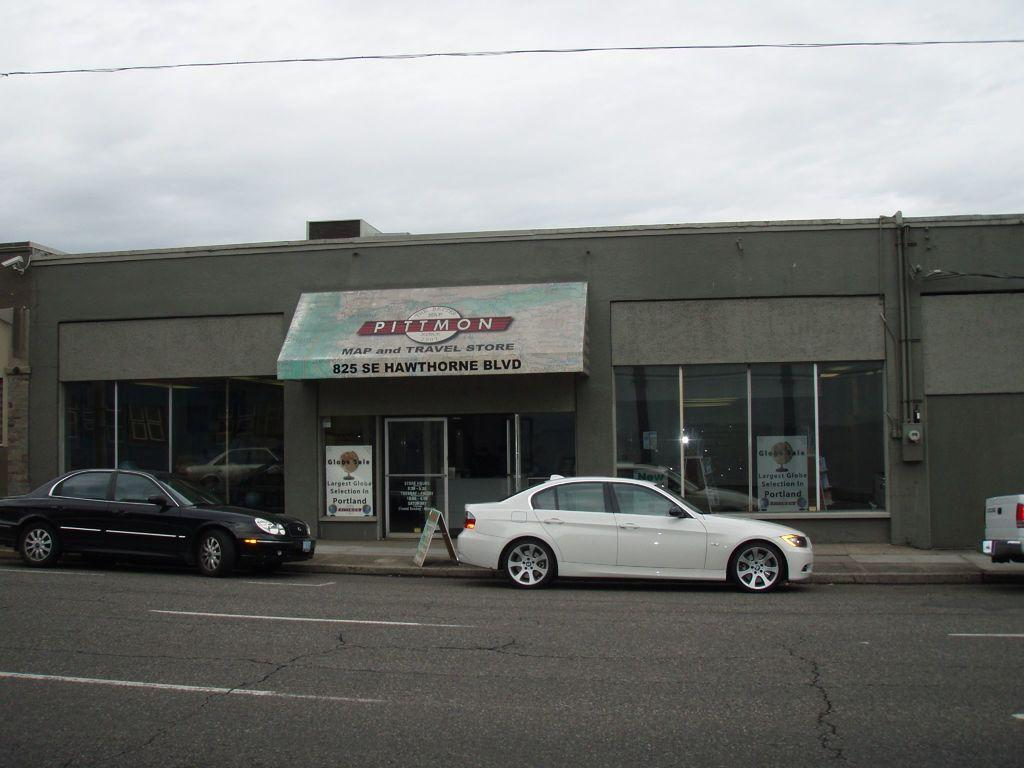What type of structure is visible in the image? There is a building in the image. What can be seen on the building? There is a name board on the building. What mode of transportation can be seen in the image? There are vehicles in the image. What other objects are present in the image? There are other objects in the image, but their specific details are not mentioned in the provided facts. What is visible at the top of the image? The sky is visible at the top of the image. What is visible at the bottom of the image? The road is visible at the bottom of the image. Can you see any toothpaste on the seashore in the image? There is no seashore or toothpaste present in the image. How many rings are visible on the building in the image? There is no mention of rings on the building in the provided facts, so we cannot determine their presence or quantity. 